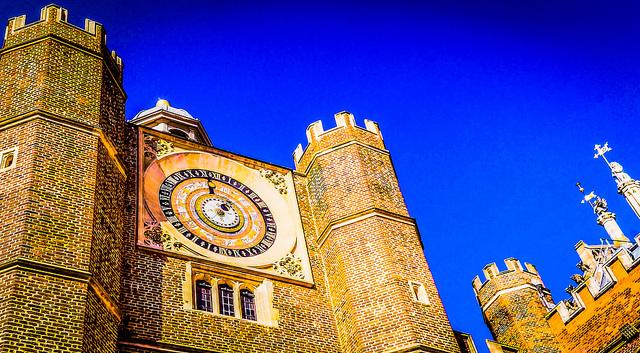What building is this?
Answer briefly. Castle. Is this a new building?
Be succinct. No. How many windows are there?
Short answer required. 5. 